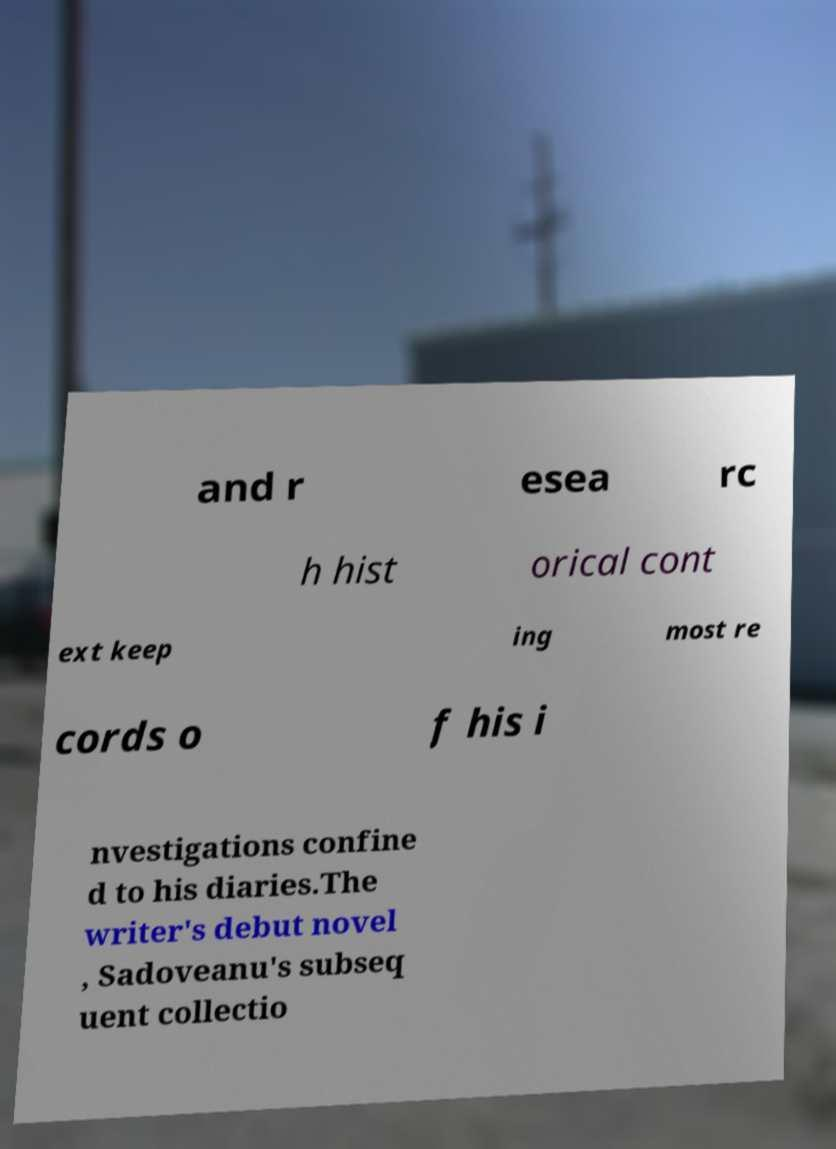Could you assist in decoding the text presented in this image and type it out clearly? and r esea rc h hist orical cont ext keep ing most re cords o f his i nvestigations confine d to his diaries.The writer's debut novel , Sadoveanu's subseq uent collectio 